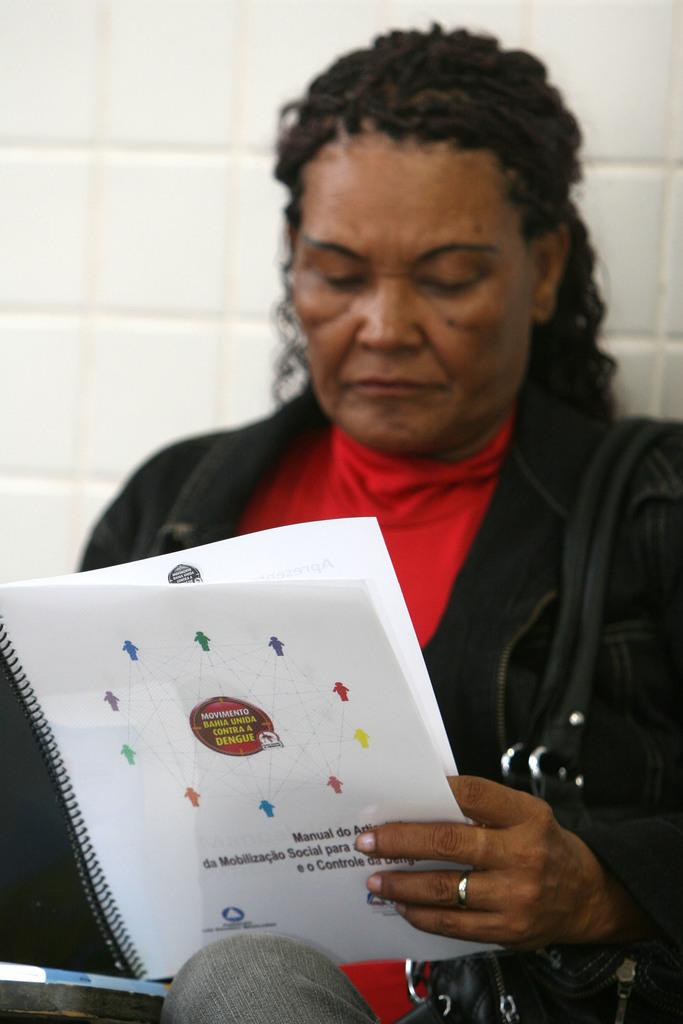Who is in the image? There is a person in the image. What is the person wearing? The person is wearing a black jacket and a red t-shirt. What is the person holding in her hand? The person is holding a book in her hand. What other object can be seen in the image? There is a black bag in the image. What is the background of the image like? There is a wall with white tiles in the background. What type of quartz can be seen in the person's hand in the image? There is no quartz present in the image; the person is holding a book. Can you tell me how many animals are visible in the zoo in the image? There is no zoo present in the image; it features a person holding a book and a black bag in front of a wall with white tiles. 